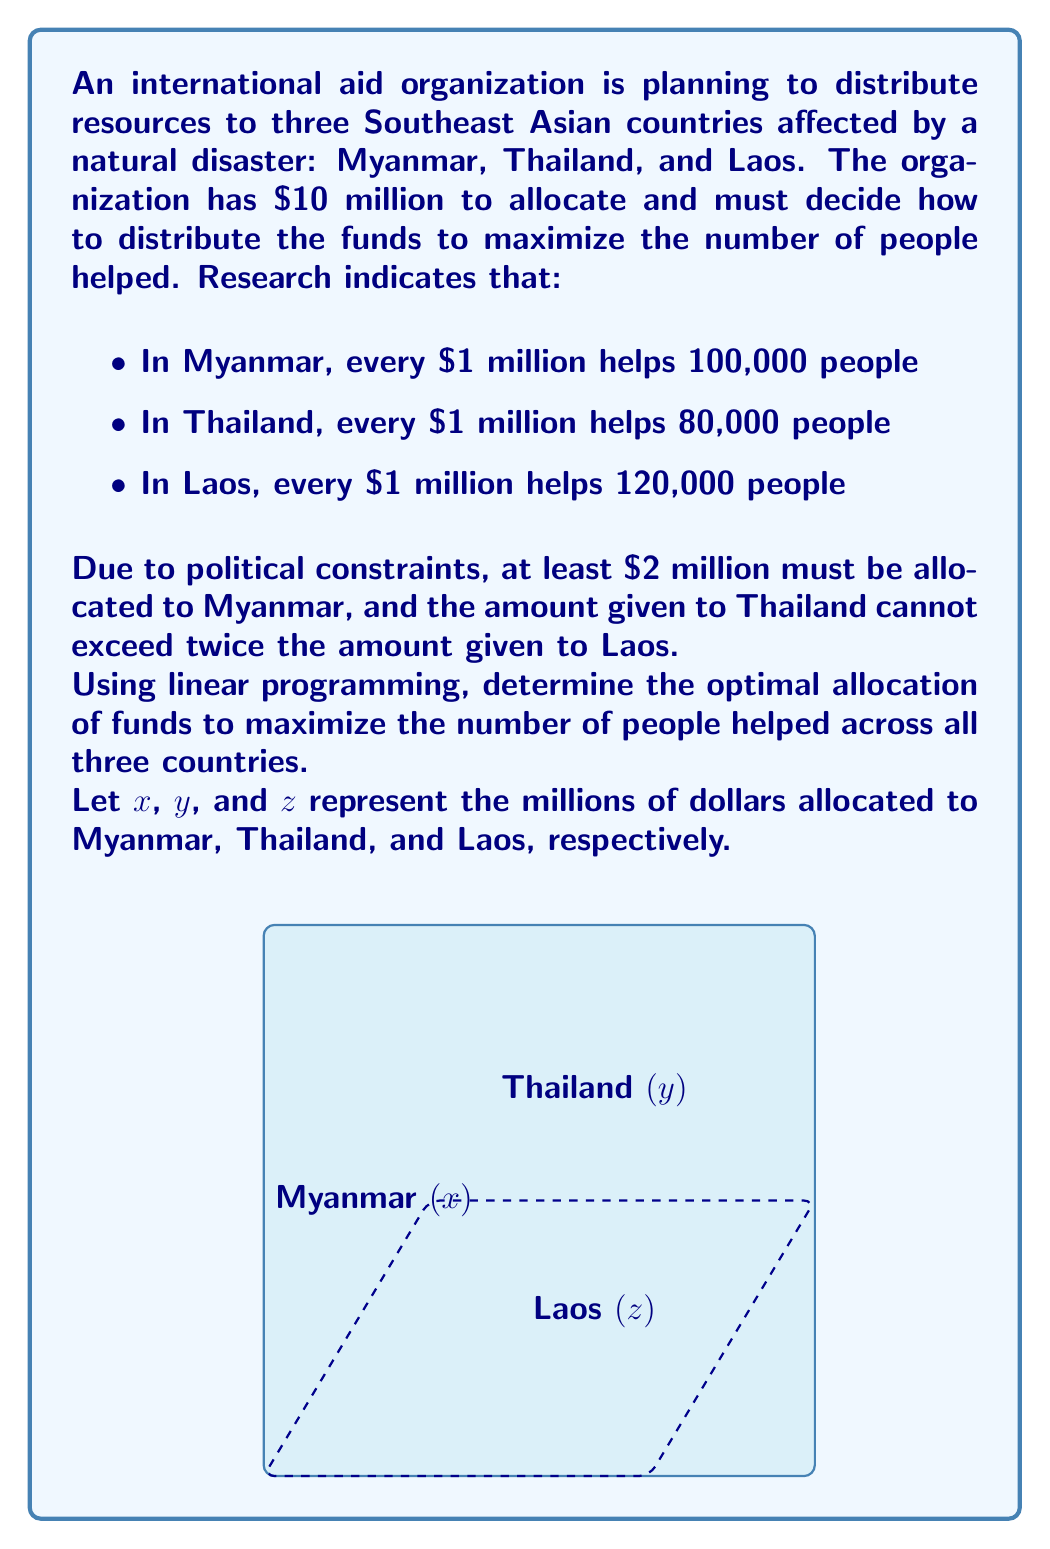Can you answer this question? Let's approach this step-by-step using linear programming:

1) First, we define our objective function. We want to maximize the total number of people helped:

   Maximize: $100,000x + 80,000y + 120,000z$

2) Now, let's list our constraints:

   a) Total budget: $x + y + z \leq 10$
   b) Minimum for Myanmar: $x \geq 2$
   c) Thailand's constraint: $y \leq 2z$
   d) Non-negativity: $x, y, z \geq 0$

3) We can simplify our objective function by dividing by 10,000:

   Maximize: $10x + 8y + 12z$

4) To solve this, we can use the simplex method or a graphical approach. Given the political context of the persona, let's use a more intuitive approach:

   - We know we must allocate at least 2 to Myanmar, so let's start there.
   - The constraint $y \leq 2z$ suggests we should allocate more to Laos than Thailand, as Laos provides more help per dollar.
   - After allocating to Myanmar, we have 8 left to split between Thailand and Laos.

5) Let's try different allocations:

   a) Myanmar: 2, Thailand: 2.67, Laos: 5.33
      Total helped: $2(100) + 2.67(80) + 5.33(120) = 1,053,600$

   b) Myanmar: 2, Thailand: 2.5, Laos: 5.5
      Total helped: $2(100) + 2.5(80) + 5.5(120) = 1,060,000$

   c) Myanmar: 2, Thailand: 2.4, Laos: 5.6
      Total helped: $2(100) + 2.4(80) + 5.6(120) = 1,064,000$

6) We can see that allocating more to Laos increases the total number of people helped. The optimal solution respects the constraint $y = 2z$ while maximizing allocation to Laos.

7) The optimal solution is:
   Myanmar (x): 2
   Laos (z): 2.67 (8/3)
   Thailand (y): 5.33 (16/3)

8) We can verify that this satisfies all constraints:
   - Total budget: $2 + 2.67 + 5.33 = 10$
   - Minimum for Myanmar: $2 \geq 2$
   - Thailand's constraint: $2.67 \leq 2(5.33)$

9) The maximum number of people helped is:
   $2(100,000) + 2.67(80,000) + 5.33(120,000) = 1,064,000$
Answer: Myanmar: $2 million, Thailand: $2.67 million, Laos: $5.33 million; 1,064,000 people helped 